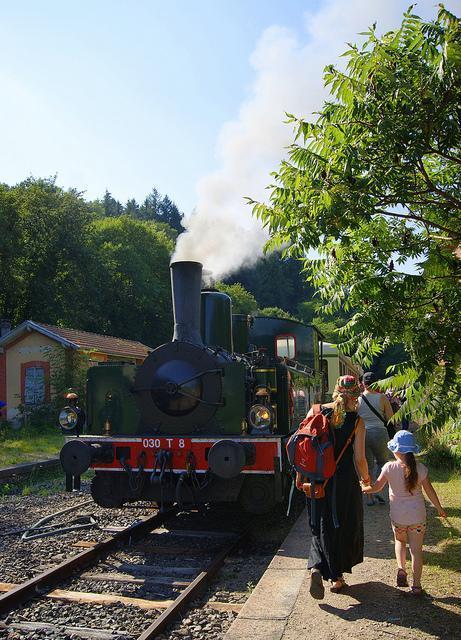How many people are there?
Give a very brief answer. 3. How many lug nuts does the trucks front wheel have?
Give a very brief answer. 0. 